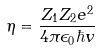<formula> <loc_0><loc_0><loc_500><loc_500>\eta = \frac { Z _ { 1 } Z _ { 2 } e ^ { 2 } } { 4 \pi \epsilon _ { 0 } \hbar { v } }</formula> 